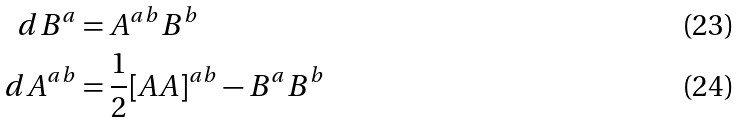<formula> <loc_0><loc_0><loc_500><loc_500>d B ^ { a } & = A ^ { a b } B ^ { b } \\ d A ^ { a b } & = \frac { 1 } { 2 } [ A A ] ^ { a b } - B ^ { a } B ^ { b }</formula> 